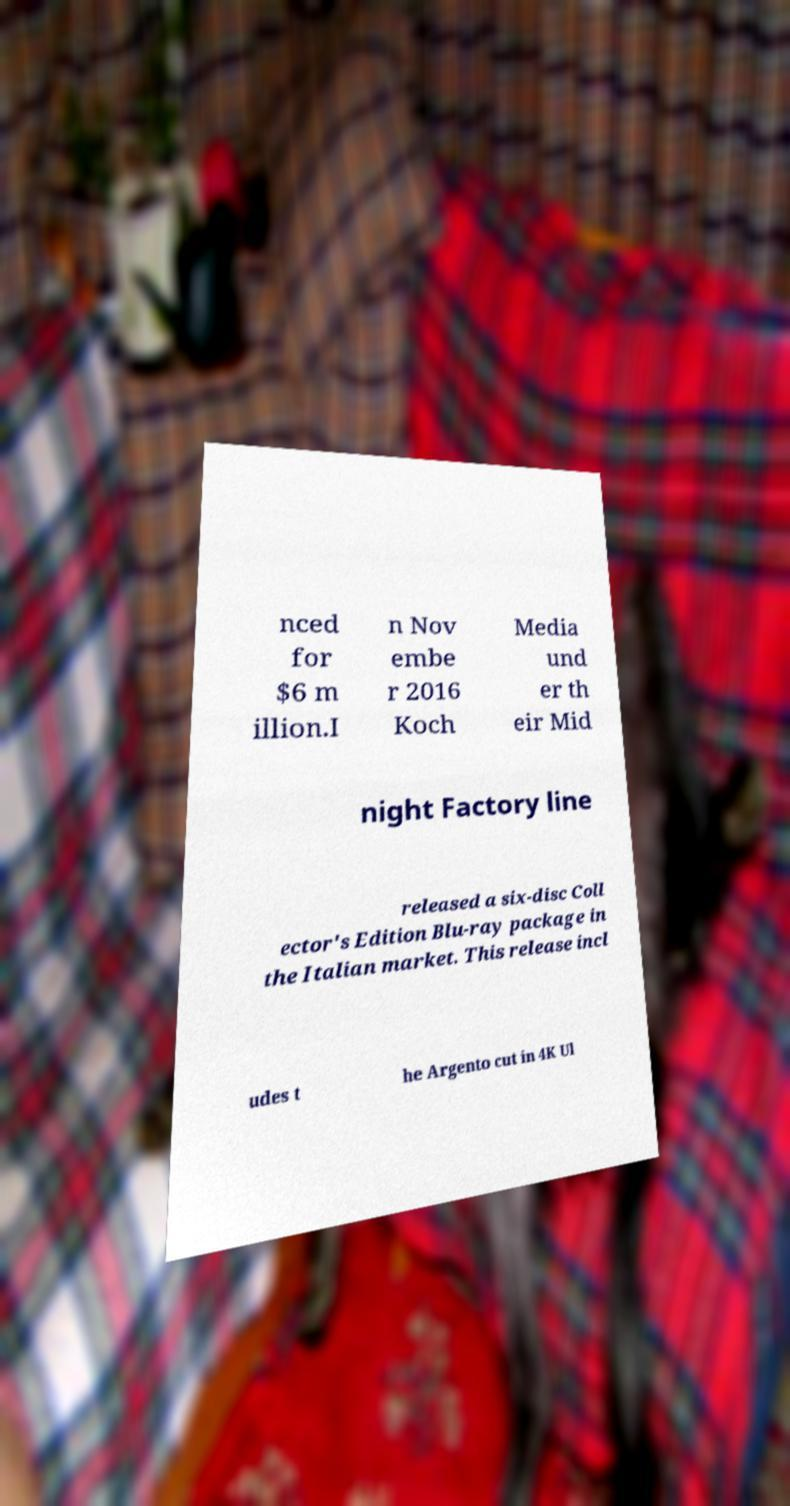Could you assist in decoding the text presented in this image and type it out clearly? nced for $6 m illion.I n Nov embe r 2016 Koch Media und er th eir Mid night Factory line released a six-disc Coll ector's Edition Blu-ray package in the Italian market. This release incl udes t he Argento cut in 4K Ul 